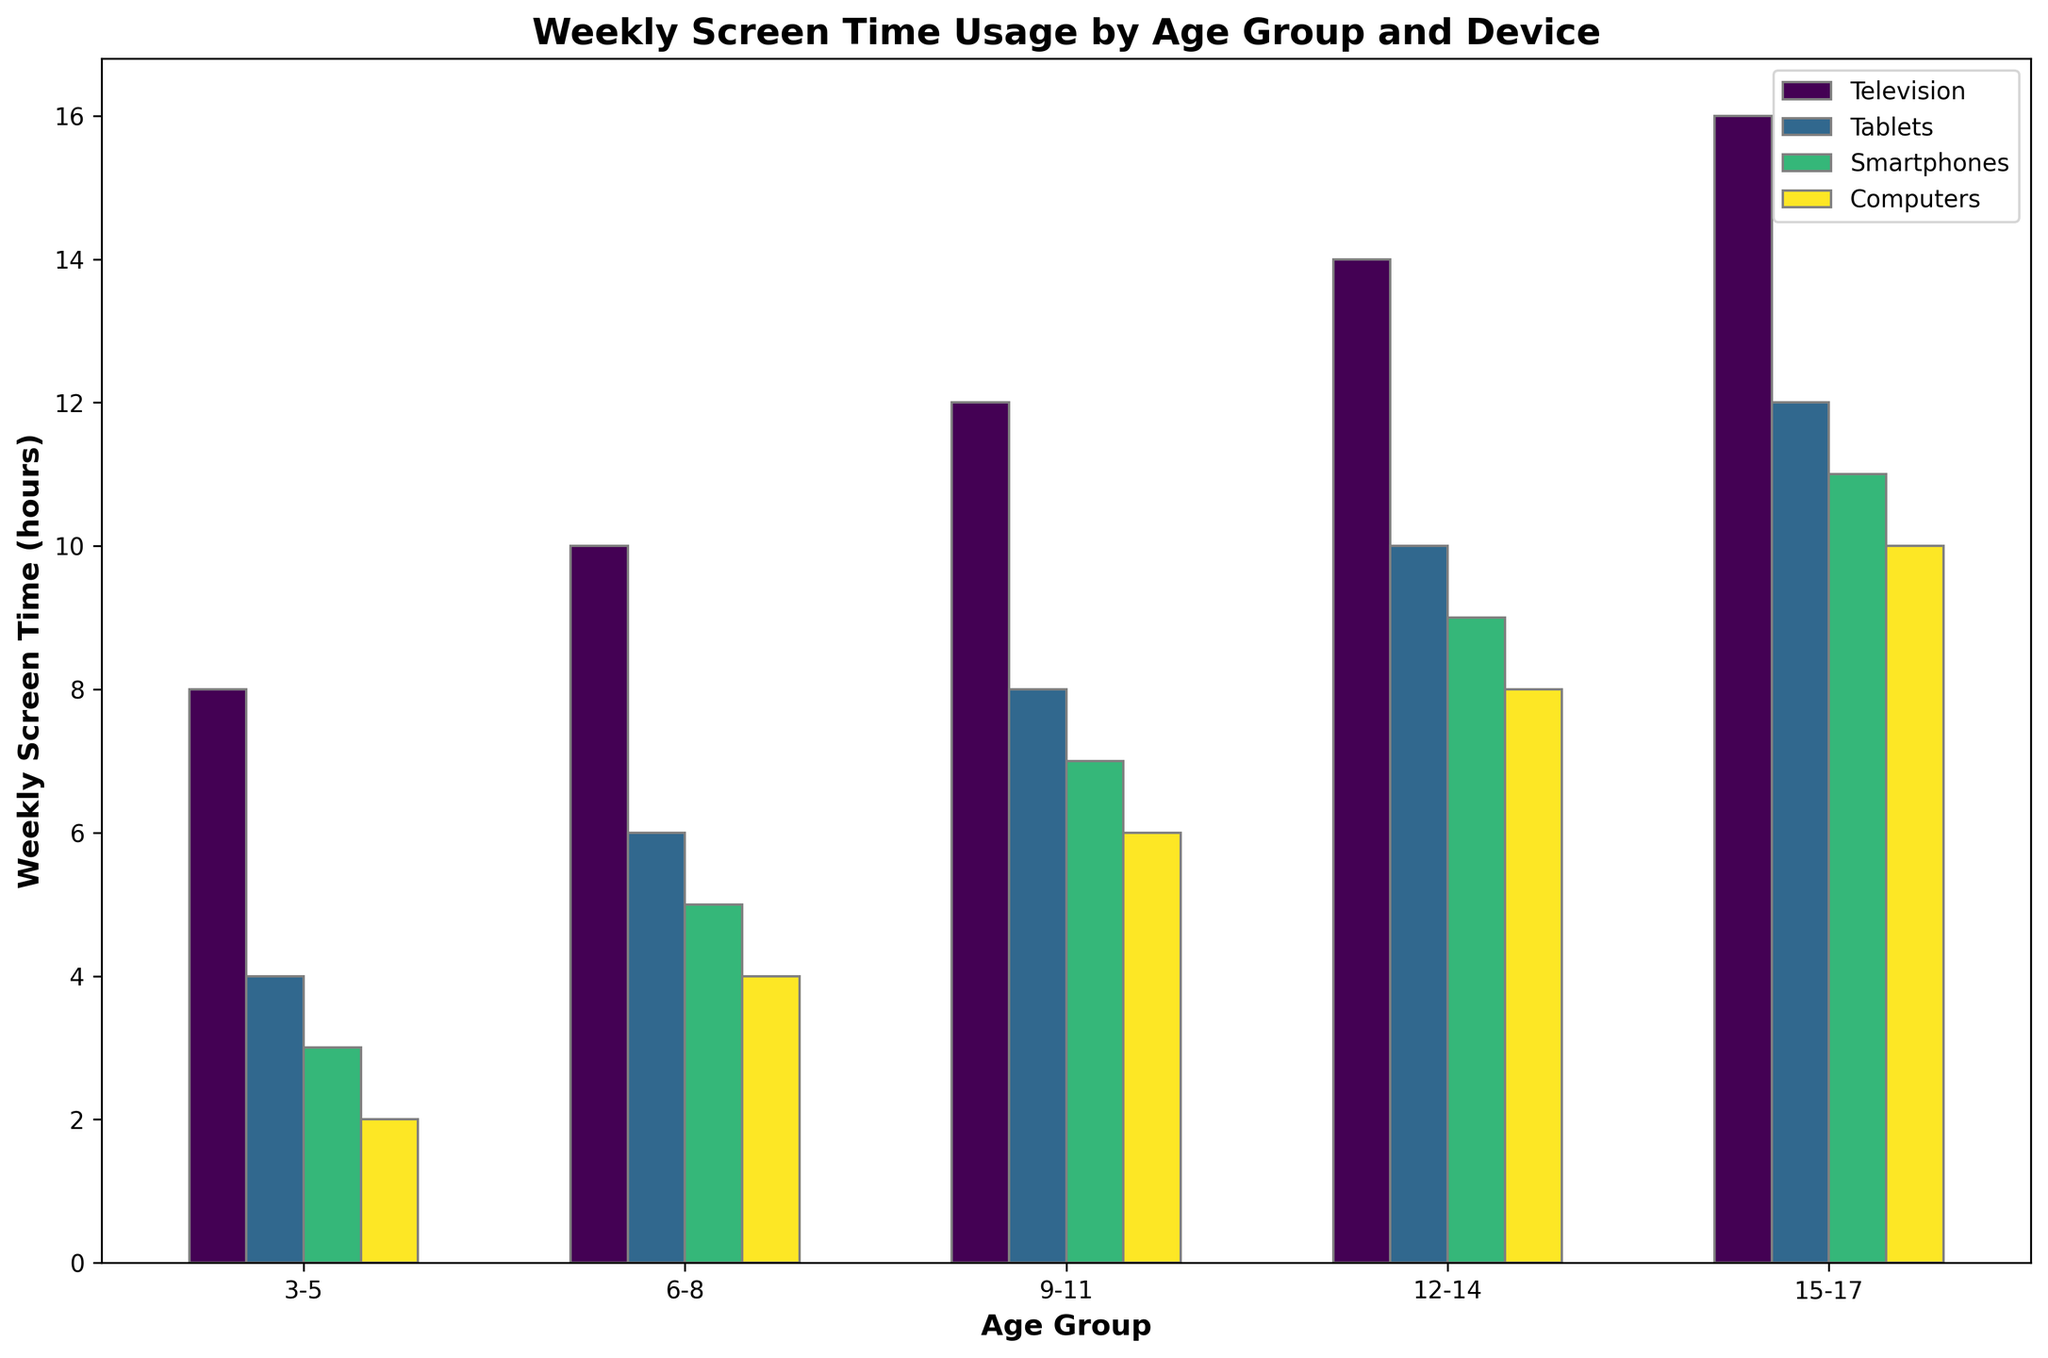What's the average weekly screen time for 6-8-year-olds across all devices? Add the weekly screen time for all devices within the 6-8 age group (10 + 6 + 5 + 4 = 25 hours) and divide by the number of devices (4). The average is 25 / 4.
Answer: 6.25 hours Which device has the highest weekly screen time for 15-17-year-olds? Look at the bars for 15-17-year-olds and identify the tallest one. The order from highest to lowest is Television, Tablets, Smartphones, Computers.
Answer: Television Is the weekly screen time on tablets for 9-11-year-olds greater than on computers for 12-14-year-olds? Compare the height of the bar for tablets (8 hours) for 9-11-year-olds with the height of the bar for computers (8 hours) for 12-14-year-olds.
Answer: No What's the total weekly screen time for all devices for 3-5-year-olds? Add up the weekly screen time for all devices in the 3-5 age group (8 + 4 + 3 + 2).
Answer: 17 hours Which age group has the lowest average weekly screen time across all devices? Calculate the average for each age group and compare:
- 3-5: (8 + 4 + 3 + 2)/4 = 4.25
- 6-8: (10 + 6 + 5 + 4)/4 = 6.25
- 9-11: (12 + 8 + 7 + 6)/4 = 8.25
- 12-14: (14 + 10 + 9 + 8)/4 = 10.25
- 15-17: (16 + 12 + 11 + 10)/4 = 12.25
The lowest average is 3-5.
Answer: 3-5 How much more time do 12-14-year-olds spend on smartphones compared to 6-8-year-olds? Subtract the weekly screen time of smartphones between the two age groups (9 - 5).
Answer: 4 hours What is the difference in weekly screen time on computers between the 15-17 and 3-5 age groups? Subtract the weekly screen time on computers for the two age groups (10 - 2).
Answer: 8 hours Which age group has the highest total weekly screen time on all devices? Calculate the total for each group and compare:
- 3-5: (8 + 4 + 3 + 2) = 17
- 6-8: (10 + 6 + 5 + 4) = 25
- 9-11: (12 + 8 + 7 + 6) = 33
- 12-14: (14 + 10 + 9 + 8) = 41
- 15-17: (16 + 12 + 11 + 10) = 49
The highest total is 15-17.
Answer: 15-17 What's the combined weekly screen time for smartphones for all age groups? Add up the weekly screen time for smartphones across all age groups (3 + 5 + 7 + 9 + 11).
Answer: 35 hours 